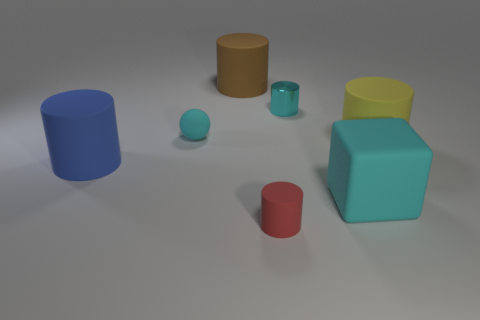Subtract all large blue cylinders. How many cylinders are left? 4 Add 2 small cyan rubber balls. How many objects exist? 9 Subtract 3 cylinders. How many cylinders are left? 2 Subtract all brown cylinders. How many cylinders are left? 4 Subtract 0 red balls. How many objects are left? 7 Subtract all blocks. How many objects are left? 6 Subtract all yellow cylinders. Subtract all blue spheres. How many cylinders are left? 4 Subtract all green cubes. How many green spheres are left? 0 Subtract all tiny rubber objects. Subtract all big objects. How many objects are left? 1 Add 5 tiny red rubber objects. How many tiny red rubber objects are left? 6 